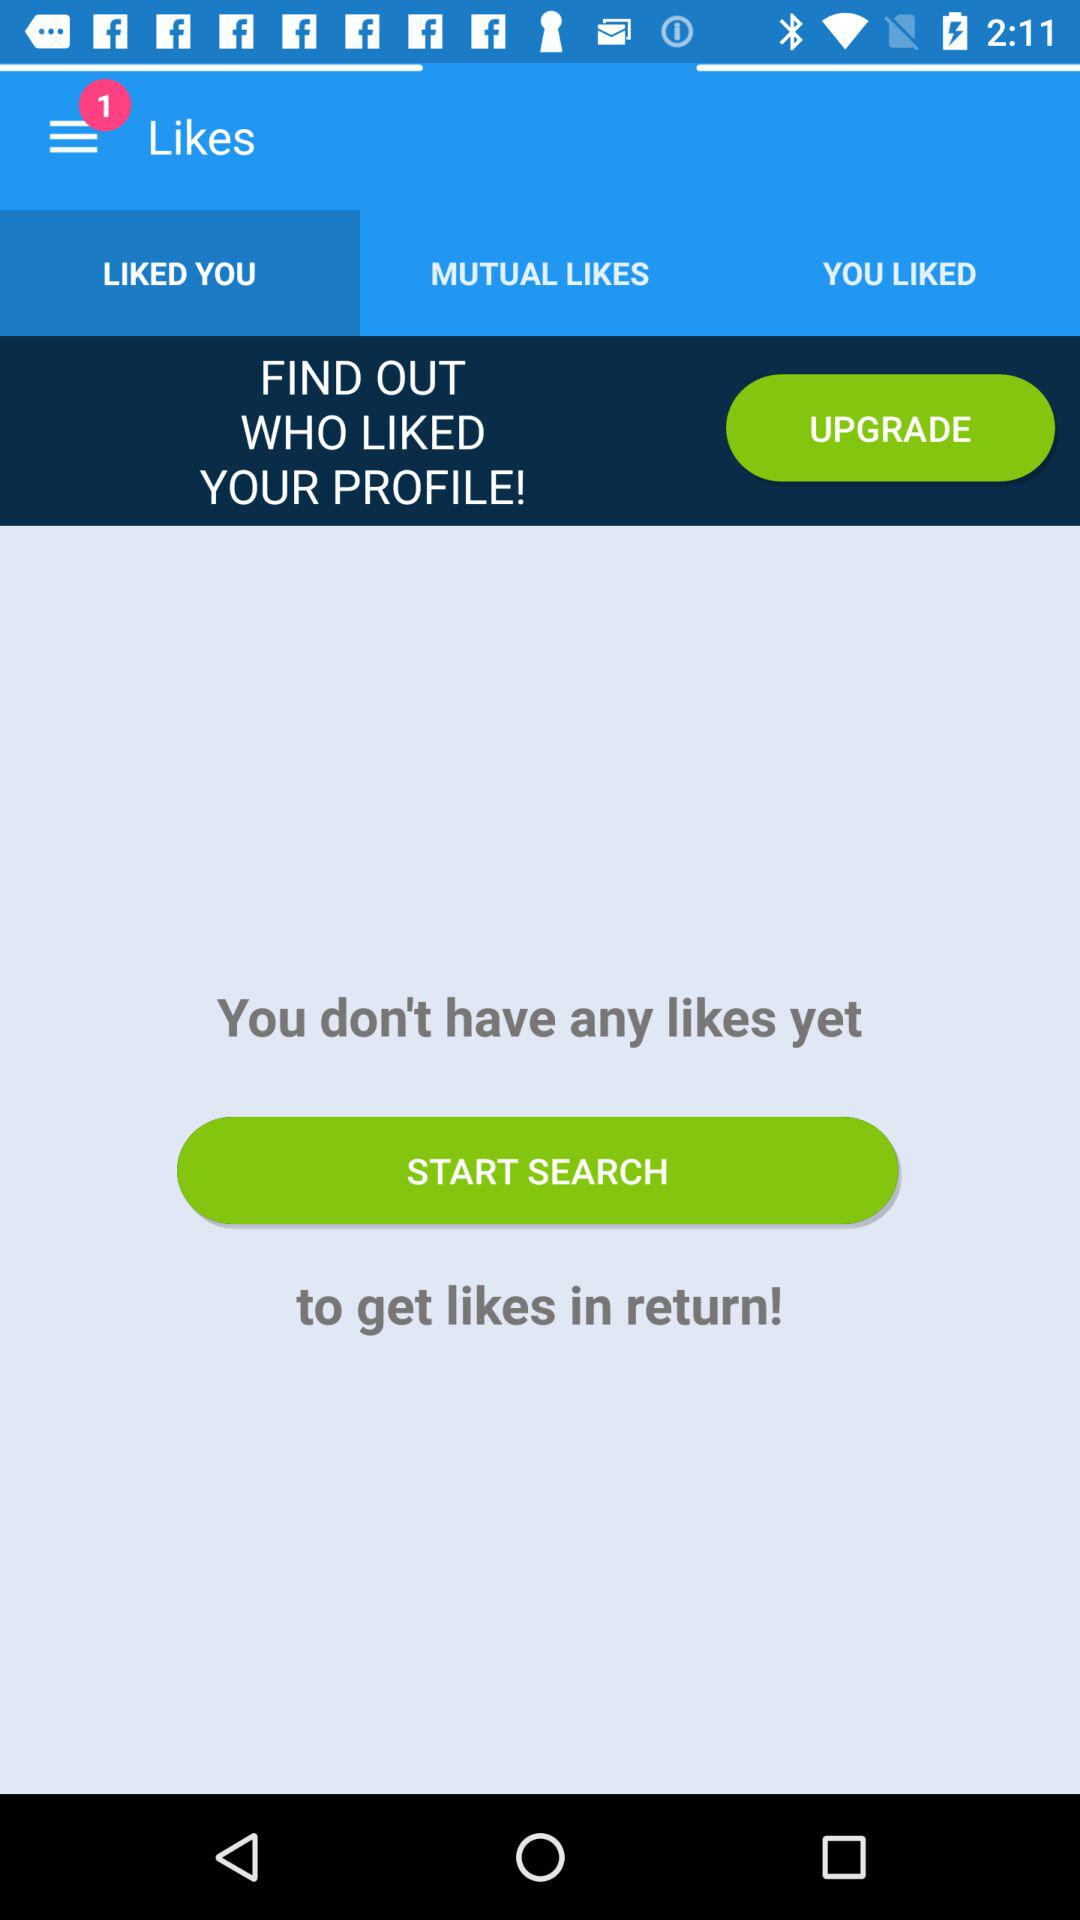What is the selected tab? The selected tab is "LIKED YOU". 